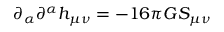<formula> <loc_0><loc_0><loc_500><loc_500>\partial _ { \alpha } \partial ^ { \alpha } h _ { \mu \nu } = - 1 6 \pi G S _ { \mu \nu }</formula> 